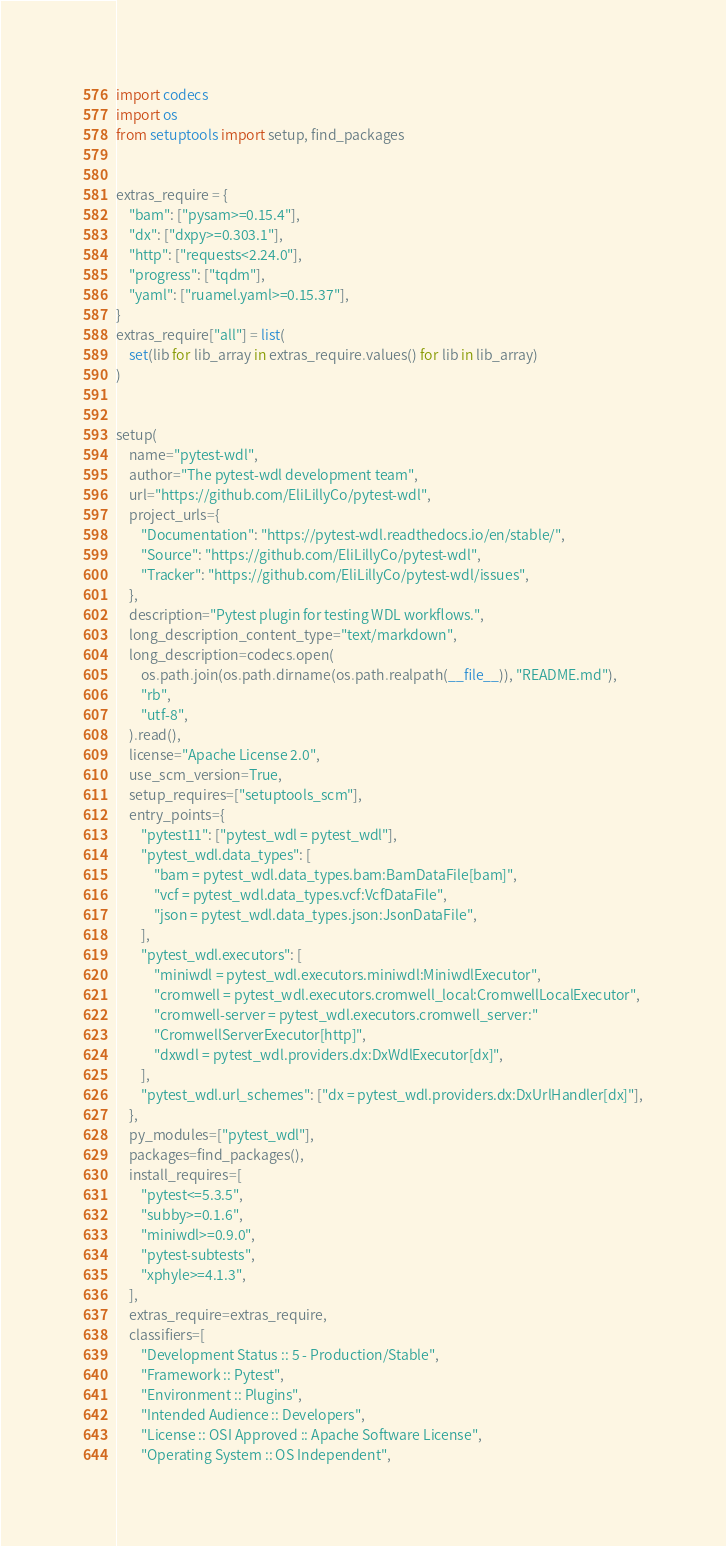<code> <loc_0><loc_0><loc_500><loc_500><_Python_>import codecs
import os
from setuptools import setup, find_packages


extras_require = {
    "bam": ["pysam>=0.15.4"],
    "dx": ["dxpy>=0.303.1"],
    "http": ["requests<2.24.0"],
    "progress": ["tqdm"],
    "yaml": ["ruamel.yaml>=0.15.37"],
}
extras_require["all"] = list(
    set(lib for lib_array in extras_require.values() for lib in lib_array)
)


setup(
    name="pytest-wdl",
    author="The pytest-wdl development team",
    url="https://github.com/EliLillyCo/pytest-wdl",
    project_urls={
        "Documentation": "https://pytest-wdl.readthedocs.io/en/stable/",
        "Source": "https://github.com/EliLillyCo/pytest-wdl",
        "Tracker": "https://github.com/EliLillyCo/pytest-wdl/issues",
    },
    description="Pytest plugin for testing WDL workflows.",
    long_description_content_type="text/markdown",
    long_description=codecs.open(
        os.path.join(os.path.dirname(os.path.realpath(__file__)), "README.md"),
        "rb",
        "utf-8",
    ).read(),
    license="Apache License 2.0",
    use_scm_version=True,
    setup_requires=["setuptools_scm"],
    entry_points={
        "pytest11": ["pytest_wdl = pytest_wdl"],
        "pytest_wdl.data_types": [
            "bam = pytest_wdl.data_types.bam:BamDataFile[bam]",
            "vcf = pytest_wdl.data_types.vcf:VcfDataFile",
            "json = pytest_wdl.data_types.json:JsonDataFile",
        ],
        "pytest_wdl.executors": [
            "miniwdl = pytest_wdl.executors.miniwdl:MiniwdlExecutor",
            "cromwell = pytest_wdl.executors.cromwell_local:CromwellLocalExecutor",
            "cromwell-server = pytest_wdl.executors.cromwell_server:"
            "CromwellServerExecutor[http]",
            "dxwdl = pytest_wdl.providers.dx:DxWdlExecutor[dx]",
        ],
        "pytest_wdl.url_schemes": ["dx = pytest_wdl.providers.dx:DxUrlHandler[dx]"],
    },
    py_modules=["pytest_wdl"],
    packages=find_packages(),
    install_requires=[
        "pytest<=5.3.5",
        "subby>=0.1.6",
        "miniwdl>=0.9.0",
        "pytest-subtests",
        "xphyle>=4.1.3",
    ],
    extras_require=extras_require,
    classifiers=[
        "Development Status :: 5 - Production/Stable",
        "Framework :: Pytest",
        "Environment :: Plugins",
        "Intended Audience :: Developers",
        "License :: OSI Approved :: Apache Software License",
        "Operating System :: OS Independent",</code> 